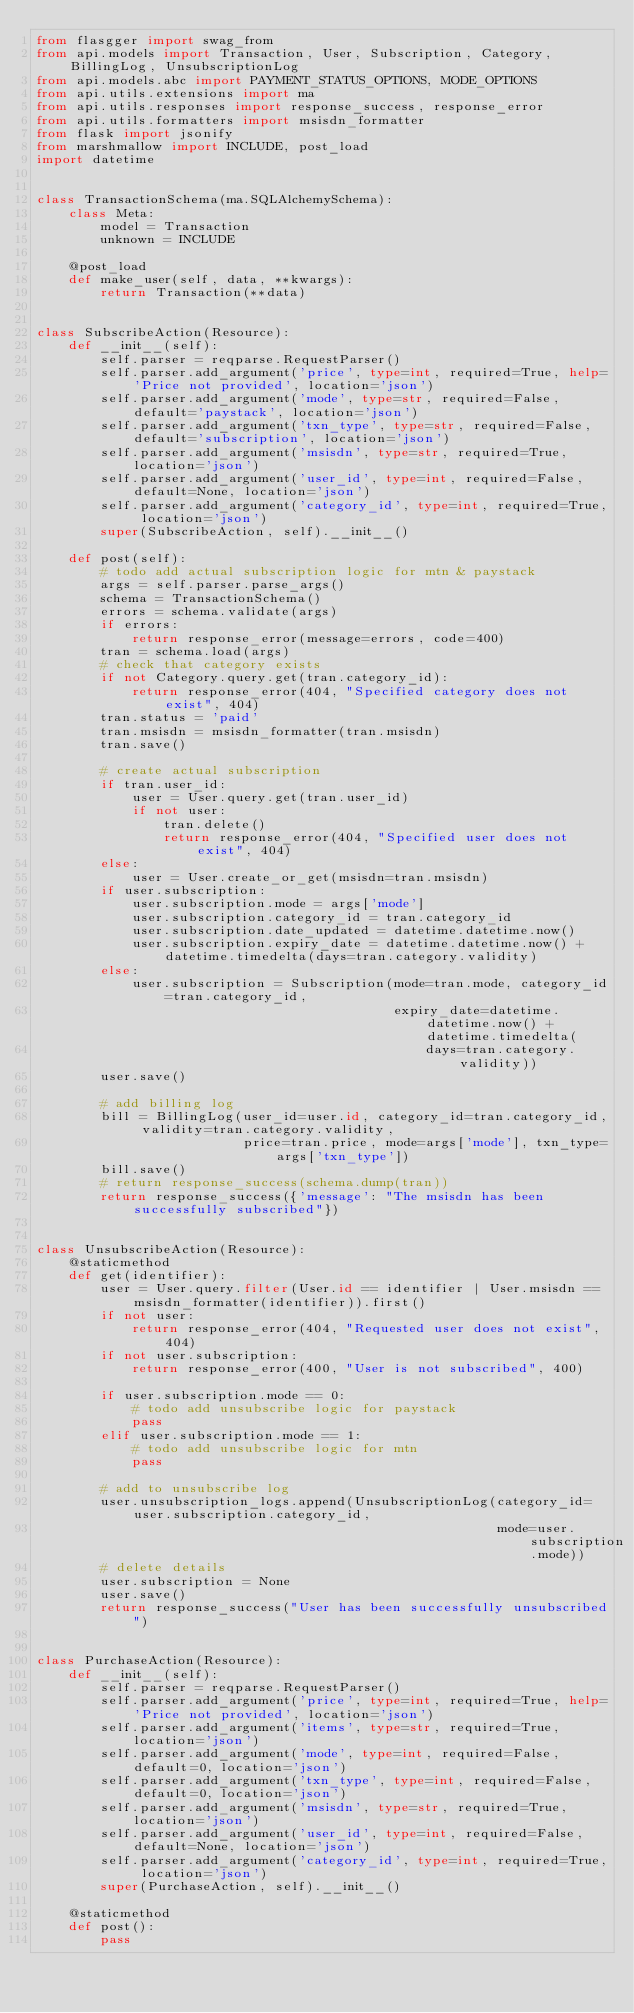<code> <loc_0><loc_0><loc_500><loc_500><_Python_>from flasgger import swag_from
from api.models import Transaction, User, Subscription, Category, BillingLog, UnsubscriptionLog
from api.models.abc import PAYMENT_STATUS_OPTIONS, MODE_OPTIONS
from api.utils.extensions import ma
from api.utils.responses import response_success, response_error
from api.utils.formatters import msisdn_formatter
from flask import jsonify
from marshmallow import INCLUDE, post_load
import datetime


class TransactionSchema(ma.SQLAlchemySchema):
    class Meta:
        model = Transaction
        unknown = INCLUDE

    @post_load
    def make_user(self, data, **kwargs):
        return Transaction(**data)


class SubscribeAction(Resource):
    def __init__(self):
        self.parser = reqparse.RequestParser()
        self.parser.add_argument('price', type=int, required=True, help='Price not provided', location='json')
        self.parser.add_argument('mode', type=str, required=False, default='paystack', location='json')
        self.parser.add_argument('txn_type', type=str, required=False, default='subscription', location='json')
        self.parser.add_argument('msisdn', type=str, required=True, location='json')
        self.parser.add_argument('user_id', type=int, required=False, default=None, location='json')
        self.parser.add_argument('category_id', type=int, required=True, location='json')
        super(SubscribeAction, self).__init__()

    def post(self):
        # todo add actual subscription logic for mtn & paystack
        args = self.parser.parse_args()
        schema = TransactionSchema()
        errors = schema.validate(args)
        if errors:
            return response_error(message=errors, code=400)
        tran = schema.load(args)
        # check that category exists
        if not Category.query.get(tran.category_id):
            return response_error(404, "Specified category does not exist", 404)
        tran.status = 'paid'
        tran.msisdn = msisdn_formatter(tran.msisdn)
        tran.save()

        # create actual subscription
        if tran.user_id:
            user = User.query.get(tran.user_id)
            if not user:
                tran.delete()
                return response_error(404, "Specified user does not exist", 404)
        else:
            user = User.create_or_get(msisdn=tran.msisdn)
        if user.subscription:
            user.subscription.mode = args['mode']
            user.subscription.category_id = tran.category_id
            user.subscription.date_updated = datetime.datetime.now()
            user.subscription.expiry_date = datetime.datetime.now() + datetime.timedelta(days=tran.category.validity)
        else:
            user.subscription = Subscription(mode=tran.mode, category_id=tran.category_id,
                                             expiry_date=datetime.datetime.now() + datetime.timedelta(
                                                 days=tran.category.validity))
        user.save()

        # add billing log
        bill = BillingLog(user_id=user.id, category_id=tran.category_id, validity=tran.category.validity,
                          price=tran.price, mode=args['mode'], txn_type=args['txn_type'])
        bill.save()
        # return response_success(schema.dump(tran))
        return response_success({'message': "The msisdn has been successfully subscribed"})


class UnsubscribeAction(Resource):
    @staticmethod
    def get(identifier):
        user = User.query.filter(User.id == identifier | User.msisdn == msisdn_formatter(identifier)).first()
        if not user:
            return response_error(404, "Requested user does not exist", 404)
        if not user.subscription:
            return response_error(400, "User is not subscribed", 400)

        if user.subscription.mode == 0:
            # todo add unsubscribe logic for paystack
            pass
        elif user.subscription.mode == 1:
            # todo add unsubscribe logic for mtn
            pass

        # add to unsubscribe log
        user.unsubscription_logs.append(UnsubscriptionLog(category_id=user.subscription.category_id,
                                                          mode=user.subscription.mode))
        # delete details
        user.subscription = None
        user.save()
        return response_success("User has been successfully unsubscribed")


class PurchaseAction(Resource):
    def __init__(self):
        self.parser = reqparse.RequestParser()
        self.parser.add_argument('price', type=int, required=True, help='Price not provided', location='json')
        self.parser.add_argument('items', type=str, required=True, location='json')
        self.parser.add_argument('mode', type=int, required=False, default=0, location='json')
        self.parser.add_argument('txn_type', type=int, required=False, default=0, location='json')
        self.parser.add_argument('msisdn', type=str, required=True, location='json')
        self.parser.add_argument('user_id', type=int, required=False, default=None, location='json')
        self.parser.add_argument('category_id', type=int, required=True, location='json')
        super(PurchaseAction, self).__init__()

    @staticmethod
    def post():
        pass</code> 